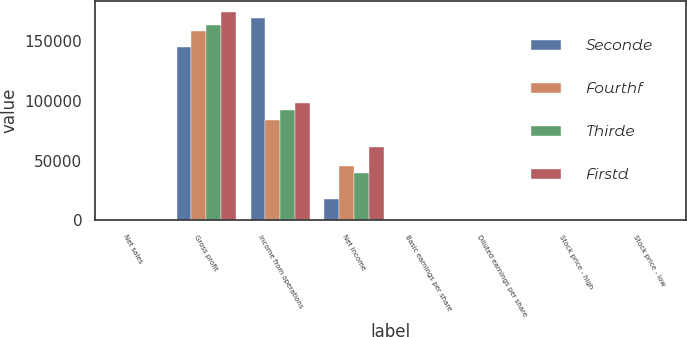<chart> <loc_0><loc_0><loc_500><loc_500><stacked_bar_chart><ecel><fcel>Net sales<fcel>Gross profit<fcel>Income from operations<fcel>Net income<fcel>Basic earnings per share<fcel>Diluted earnings per share<fcel>Stock price - high<fcel>Stock price - low<nl><fcel>Seconde<fcel>35.285<fcel>145135<fcel>169110<fcel>17844<fcel>0.18<fcel>0.18<fcel>30.62<fcel>24.82<nl><fcel>Fourthf<fcel>35.285<fcel>158015<fcel>83858<fcel>45154<fcel>0.47<fcel>0.46<fcel>29.8<fcel>25.77<nl><fcel>Thirde<fcel>35.285<fcel>163102<fcel>92072<fcel>39791<fcel>0.41<fcel>0.41<fcel>36.68<fcel>27.59<nl><fcel>Firstd<fcel>35.285<fcel>174339<fcel>98419<fcel>61031<fcel>0.63<fcel>0.63<fcel>38.67<fcel>33.89<nl></chart> 